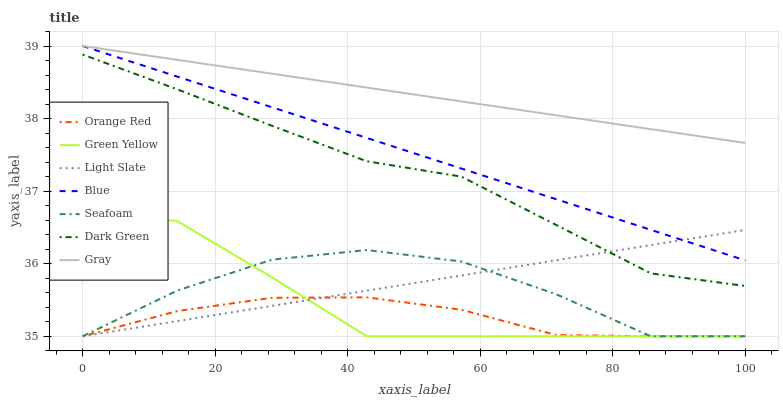Does Orange Red have the minimum area under the curve?
Answer yes or no. Yes. Does Gray have the maximum area under the curve?
Answer yes or no. Yes. Does Light Slate have the minimum area under the curve?
Answer yes or no. No. Does Light Slate have the maximum area under the curve?
Answer yes or no. No. Is Gray the smoothest?
Answer yes or no. Yes. Is Seafoam the roughest?
Answer yes or no. Yes. Is Light Slate the smoothest?
Answer yes or no. No. Is Light Slate the roughest?
Answer yes or no. No. Does Light Slate have the lowest value?
Answer yes or no. Yes. Does Gray have the lowest value?
Answer yes or no. No. Does Gray have the highest value?
Answer yes or no. Yes. Does Light Slate have the highest value?
Answer yes or no. No. Is Seafoam less than Blue?
Answer yes or no. Yes. Is Blue greater than Green Yellow?
Answer yes or no. Yes. Does Gray intersect Blue?
Answer yes or no. Yes. Is Gray less than Blue?
Answer yes or no. No. Is Gray greater than Blue?
Answer yes or no. No. Does Seafoam intersect Blue?
Answer yes or no. No. 